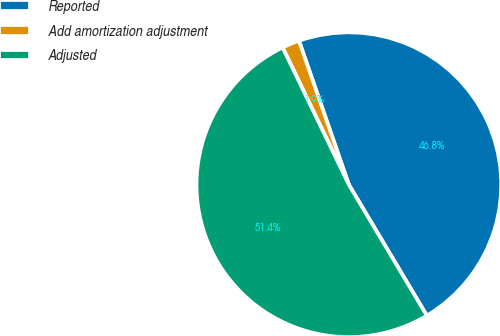<chart> <loc_0><loc_0><loc_500><loc_500><pie_chart><fcel>Reported<fcel>Add amortization adjustment<fcel>Adjusted<nl><fcel>46.76%<fcel>1.85%<fcel>51.39%<nl></chart> 